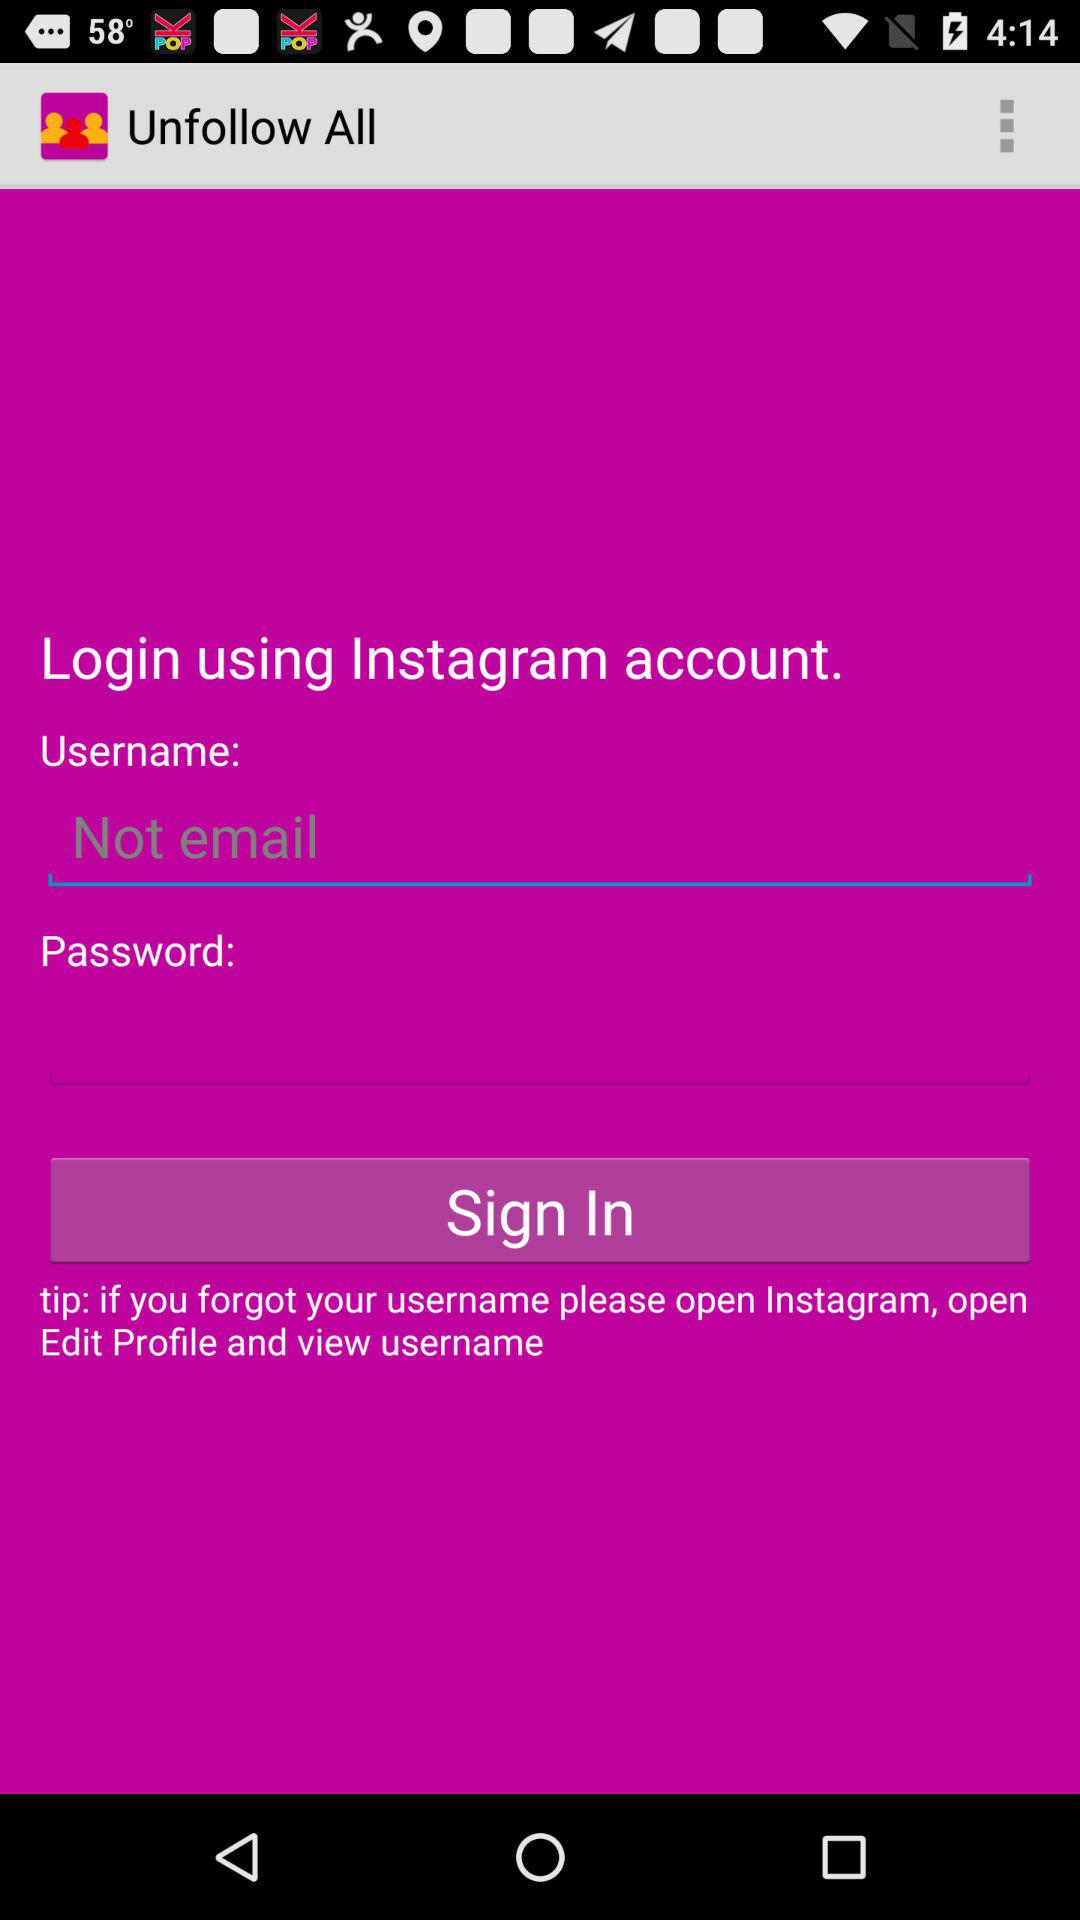How many text inputs are there for the user to fill out?
Answer the question using a single word or phrase. 2 